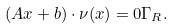Convert formula to latex. <formula><loc_0><loc_0><loc_500><loc_500>( A x + b ) \cdot \nu ( x ) = 0 \Gamma _ { R } .</formula> 